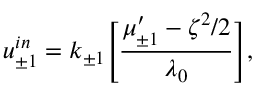Convert formula to latex. <formula><loc_0><loc_0><loc_500><loc_500>u _ { \pm 1 } ^ { i n } = k _ { \pm 1 } \left [ \frac { \mu _ { \pm 1 } ^ { \prime } - \zeta ^ { 2 } / 2 } { \lambda _ { 0 } } \right ] ,</formula> 